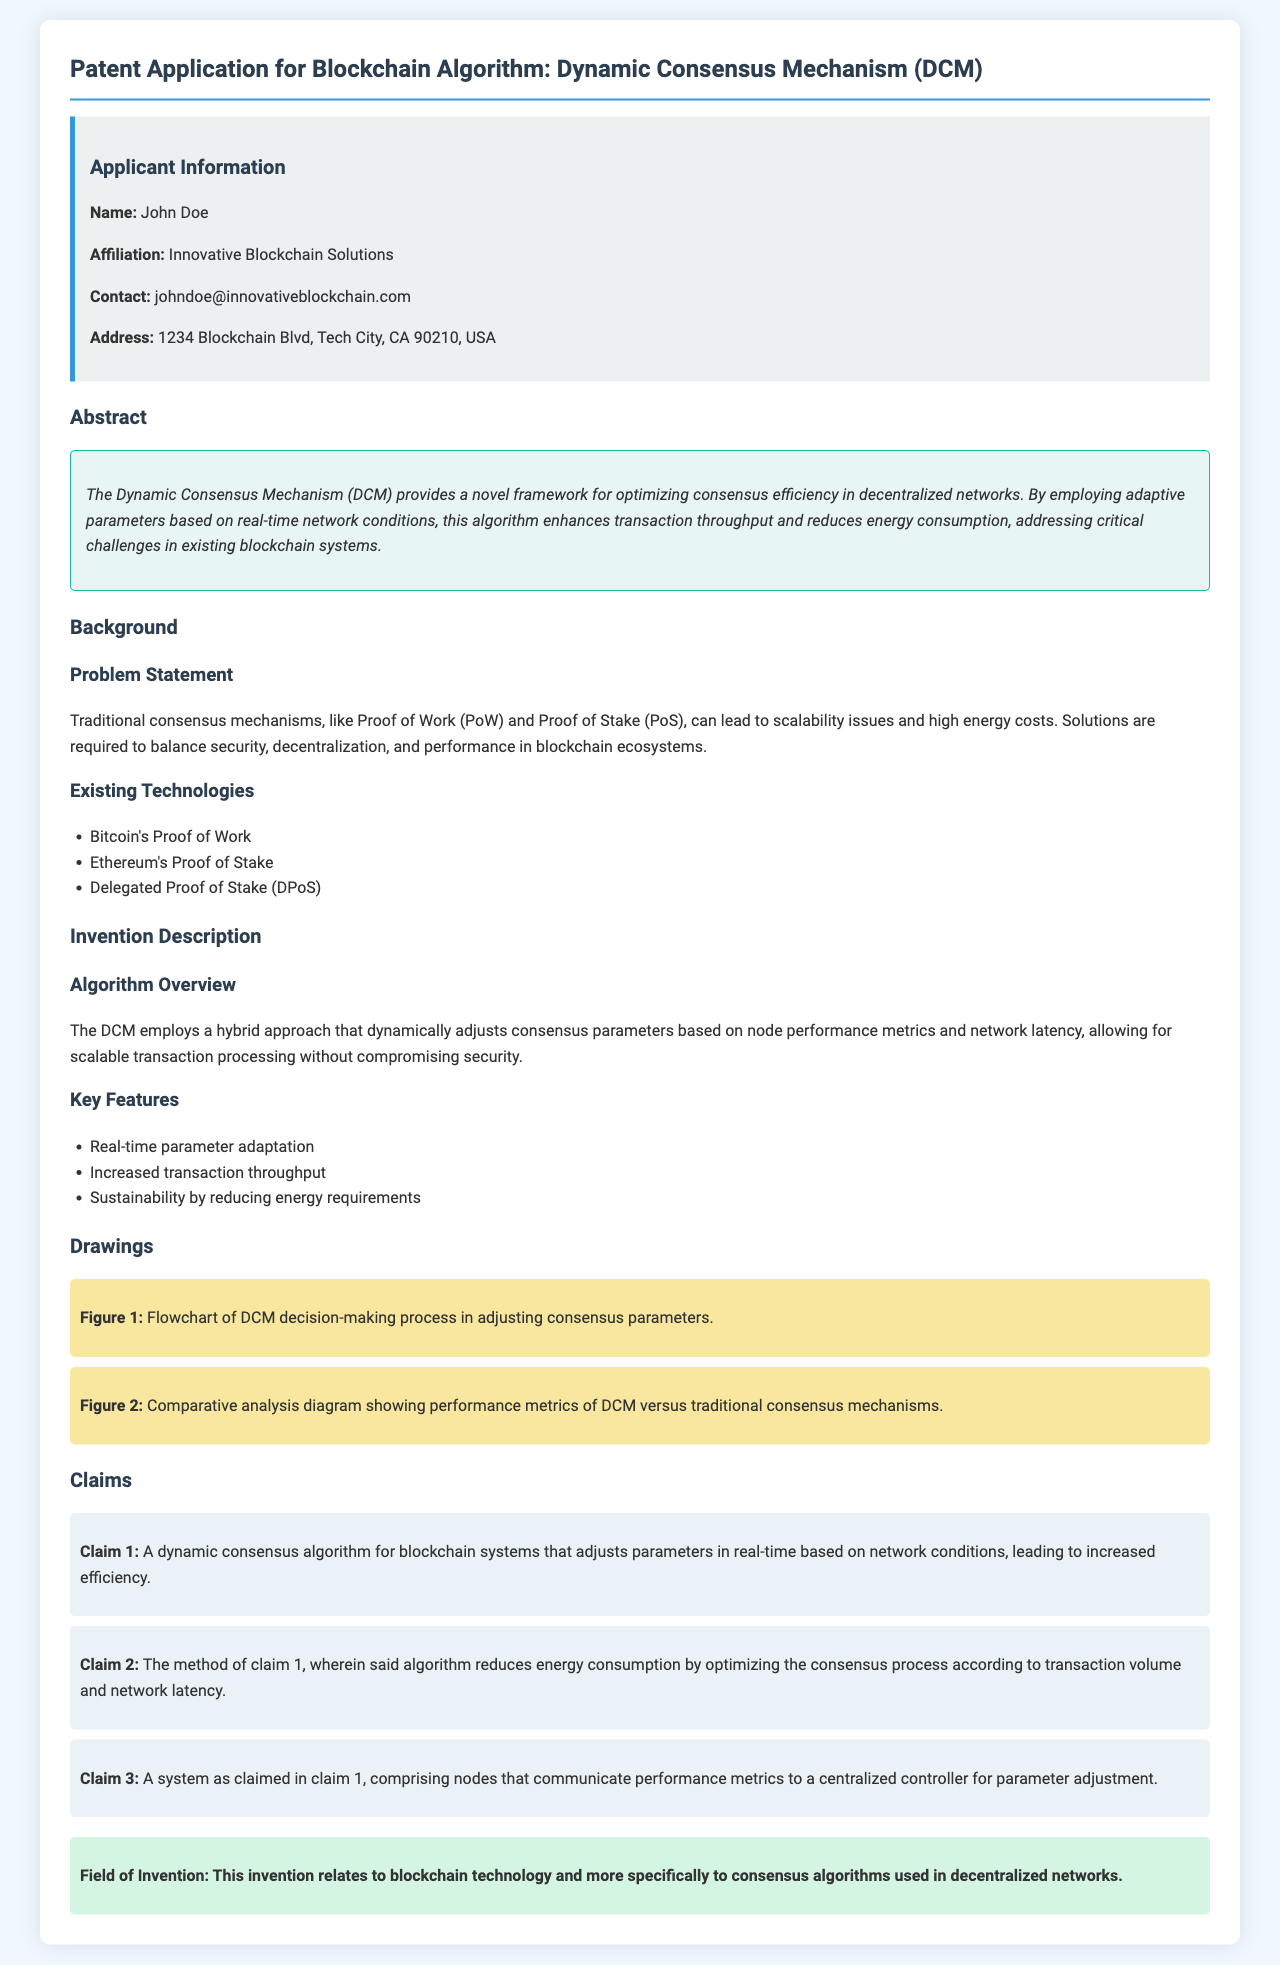What is the name of the applicant? The name of the applicant is located in the applicant information section of the document.
Answer: John Doe What is the title of the patent application? The title can be found at the top of the document under the main heading.
Answer: Dynamic Consensus Mechanism (DCM) What is claimed in Claim 2? Claim 2 summarizes the method of reducing energy consumption in relation to the algorithm outlined.
Answer: Reduces energy consumption by optimizing the consensus process according to transaction volume and network latency How many key features are listed in the invention description? The number of key features can be counted from the list provided in the document.
Answer: Three What does the dynamic consensus mechanism aim to enhance? The aim of the DCM can be derived from the abstract and invention description regarding its functionality.
Answer: Transaction throughput What field does this invention relate to? The field of invention is stated under a specific section in the document.
Answer: Blockchain technology What is the affiliation of the applicant? The applicant's affiliation is found in the applicant information section.
Answer: Innovative Blockchain Solutions How many drawings are included in the patent application? The number of drawings can be counted from the drawings section of the document.
Answer: Two 